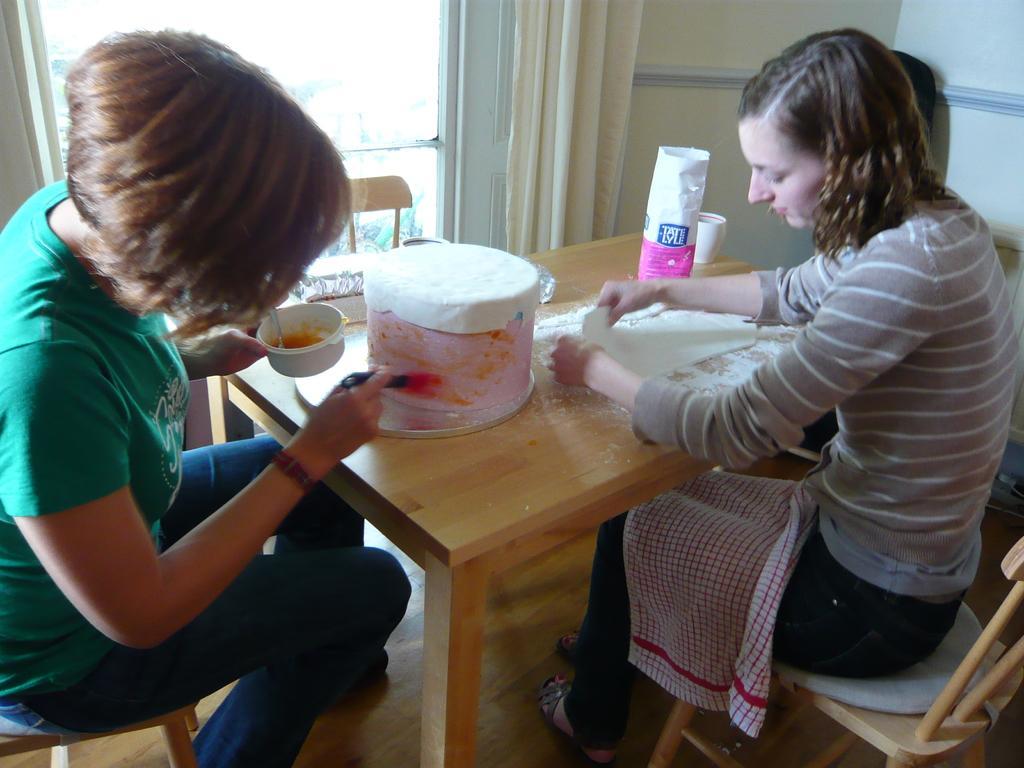Please provide a concise description of this image. In this picture there are two people sitting on the table and preparing cake. There is also a cup , floor , brushes on it. In the background we observe a glass window and a curtain. 